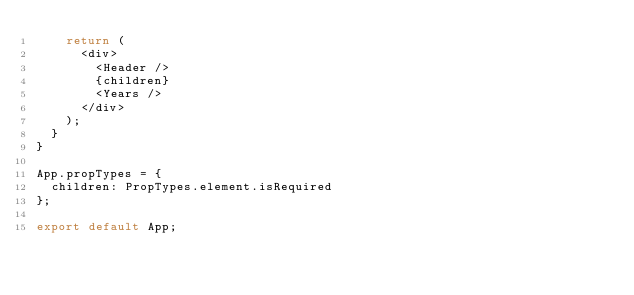<code> <loc_0><loc_0><loc_500><loc_500><_JavaScript_>    return (
      <div>
        <Header />
        {children}
        <Years />
      </div>
    );
  }
}

App.propTypes = {
  children: PropTypes.element.isRequired
};

export default App;
</code> 